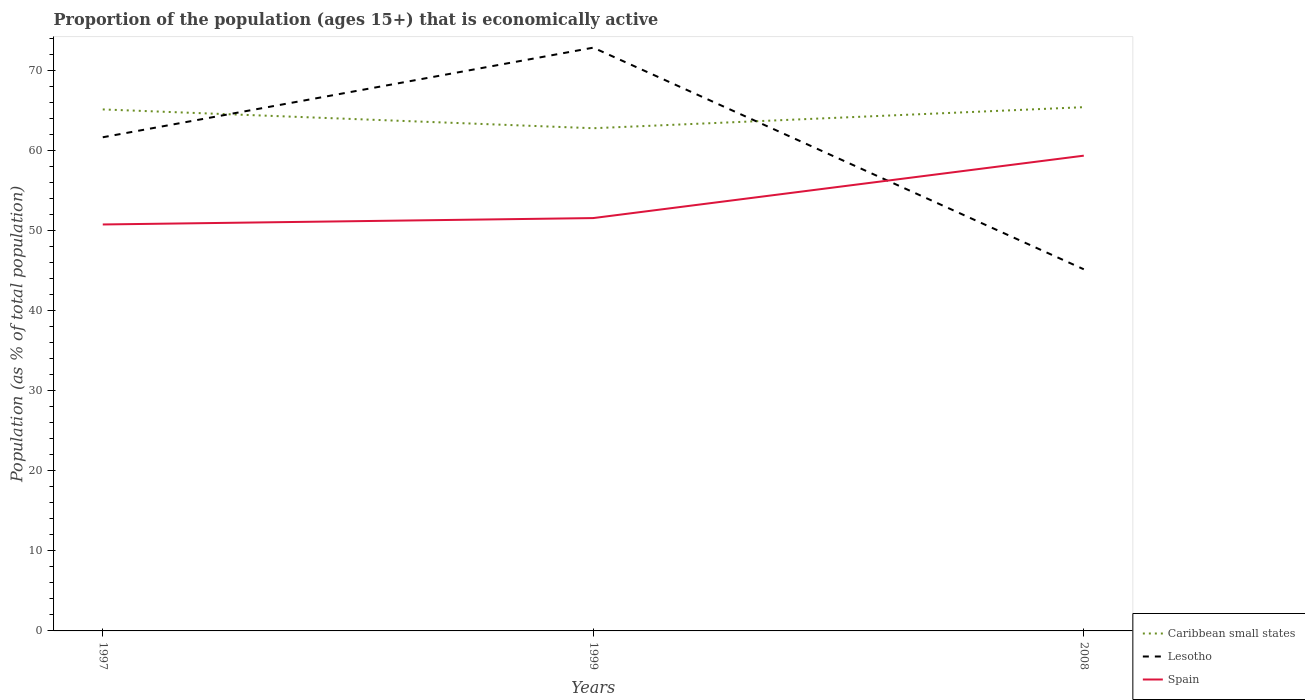Does the line corresponding to Lesotho intersect with the line corresponding to Spain?
Make the answer very short. Yes. Is the number of lines equal to the number of legend labels?
Provide a succinct answer. Yes. Across all years, what is the maximum proportion of the population that is economically active in Lesotho?
Give a very brief answer. 45.2. What is the total proportion of the population that is economically active in Spain in the graph?
Your response must be concise. -7.8. What is the difference between the highest and the second highest proportion of the population that is economically active in Spain?
Give a very brief answer. 8.6. Is the proportion of the population that is economically active in Lesotho strictly greater than the proportion of the population that is economically active in Caribbean small states over the years?
Offer a very short reply. No. How many lines are there?
Your response must be concise. 3. How many years are there in the graph?
Your answer should be very brief. 3. Does the graph contain any zero values?
Give a very brief answer. No. Does the graph contain grids?
Give a very brief answer. No. Where does the legend appear in the graph?
Make the answer very short. Bottom right. How are the legend labels stacked?
Your response must be concise. Vertical. What is the title of the graph?
Your answer should be compact. Proportion of the population (ages 15+) that is economically active. What is the label or title of the Y-axis?
Provide a short and direct response. Population (as % of total population). What is the Population (as % of total population) in Caribbean small states in 1997?
Provide a short and direct response. 65.18. What is the Population (as % of total population) of Lesotho in 1997?
Make the answer very short. 61.7. What is the Population (as % of total population) in Spain in 1997?
Ensure brevity in your answer.  50.8. What is the Population (as % of total population) in Caribbean small states in 1999?
Ensure brevity in your answer.  62.83. What is the Population (as % of total population) in Lesotho in 1999?
Keep it short and to the point. 72.9. What is the Population (as % of total population) of Spain in 1999?
Make the answer very short. 51.6. What is the Population (as % of total population) of Caribbean small states in 2008?
Provide a short and direct response. 65.46. What is the Population (as % of total population) in Lesotho in 2008?
Keep it short and to the point. 45.2. What is the Population (as % of total population) in Spain in 2008?
Provide a short and direct response. 59.4. Across all years, what is the maximum Population (as % of total population) in Caribbean small states?
Provide a succinct answer. 65.46. Across all years, what is the maximum Population (as % of total population) of Lesotho?
Your answer should be compact. 72.9. Across all years, what is the maximum Population (as % of total population) of Spain?
Make the answer very short. 59.4. Across all years, what is the minimum Population (as % of total population) in Caribbean small states?
Provide a succinct answer. 62.83. Across all years, what is the minimum Population (as % of total population) of Lesotho?
Offer a terse response. 45.2. Across all years, what is the minimum Population (as % of total population) of Spain?
Your response must be concise. 50.8. What is the total Population (as % of total population) in Caribbean small states in the graph?
Give a very brief answer. 193.47. What is the total Population (as % of total population) in Lesotho in the graph?
Provide a short and direct response. 179.8. What is the total Population (as % of total population) in Spain in the graph?
Your answer should be very brief. 161.8. What is the difference between the Population (as % of total population) in Caribbean small states in 1997 and that in 1999?
Offer a very short reply. 2.35. What is the difference between the Population (as % of total population) of Lesotho in 1997 and that in 1999?
Offer a very short reply. -11.2. What is the difference between the Population (as % of total population) of Spain in 1997 and that in 1999?
Your answer should be very brief. -0.8. What is the difference between the Population (as % of total population) of Caribbean small states in 1997 and that in 2008?
Offer a very short reply. -0.28. What is the difference between the Population (as % of total population) in Lesotho in 1997 and that in 2008?
Give a very brief answer. 16.5. What is the difference between the Population (as % of total population) of Spain in 1997 and that in 2008?
Your answer should be very brief. -8.6. What is the difference between the Population (as % of total population) of Caribbean small states in 1999 and that in 2008?
Your answer should be very brief. -2.63. What is the difference between the Population (as % of total population) in Lesotho in 1999 and that in 2008?
Give a very brief answer. 27.7. What is the difference between the Population (as % of total population) in Caribbean small states in 1997 and the Population (as % of total population) in Lesotho in 1999?
Ensure brevity in your answer.  -7.72. What is the difference between the Population (as % of total population) of Caribbean small states in 1997 and the Population (as % of total population) of Spain in 1999?
Give a very brief answer. 13.58. What is the difference between the Population (as % of total population) of Caribbean small states in 1997 and the Population (as % of total population) of Lesotho in 2008?
Keep it short and to the point. 19.98. What is the difference between the Population (as % of total population) in Caribbean small states in 1997 and the Population (as % of total population) in Spain in 2008?
Offer a very short reply. 5.78. What is the difference between the Population (as % of total population) of Lesotho in 1997 and the Population (as % of total population) of Spain in 2008?
Give a very brief answer. 2.3. What is the difference between the Population (as % of total population) of Caribbean small states in 1999 and the Population (as % of total population) of Lesotho in 2008?
Keep it short and to the point. 17.63. What is the difference between the Population (as % of total population) of Caribbean small states in 1999 and the Population (as % of total population) of Spain in 2008?
Offer a very short reply. 3.43. What is the average Population (as % of total population) in Caribbean small states per year?
Your answer should be very brief. 64.49. What is the average Population (as % of total population) in Lesotho per year?
Keep it short and to the point. 59.93. What is the average Population (as % of total population) in Spain per year?
Offer a very short reply. 53.93. In the year 1997, what is the difference between the Population (as % of total population) in Caribbean small states and Population (as % of total population) in Lesotho?
Your answer should be very brief. 3.48. In the year 1997, what is the difference between the Population (as % of total population) of Caribbean small states and Population (as % of total population) of Spain?
Give a very brief answer. 14.38. In the year 1997, what is the difference between the Population (as % of total population) in Lesotho and Population (as % of total population) in Spain?
Keep it short and to the point. 10.9. In the year 1999, what is the difference between the Population (as % of total population) in Caribbean small states and Population (as % of total population) in Lesotho?
Provide a short and direct response. -10.07. In the year 1999, what is the difference between the Population (as % of total population) of Caribbean small states and Population (as % of total population) of Spain?
Keep it short and to the point. 11.23. In the year 1999, what is the difference between the Population (as % of total population) of Lesotho and Population (as % of total population) of Spain?
Your response must be concise. 21.3. In the year 2008, what is the difference between the Population (as % of total population) in Caribbean small states and Population (as % of total population) in Lesotho?
Make the answer very short. 20.26. In the year 2008, what is the difference between the Population (as % of total population) in Caribbean small states and Population (as % of total population) in Spain?
Your answer should be compact. 6.06. In the year 2008, what is the difference between the Population (as % of total population) of Lesotho and Population (as % of total population) of Spain?
Provide a short and direct response. -14.2. What is the ratio of the Population (as % of total population) of Caribbean small states in 1997 to that in 1999?
Your response must be concise. 1.04. What is the ratio of the Population (as % of total population) in Lesotho in 1997 to that in 1999?
Give a very brief answer. 0.85. What is the ratio of the Population (as % of total population) in Spain in 1997 to that in 1999?
Make the answer very short. 0.98. What is the ratio of the Population (as % of total population) in Lesotho in 1997 to that in 2008?
Your answer should be compact. 1.36. What is the ratio of the Population (as % of total population) in Spain in 1997 to that in 2008?
Keep it short and to the point. 0.86. What is the ratio of the Population (as % of total population) of Caribbean small states in 1999 to that in 2008?
Give a very brief answer. 0.96. What is the ratio of the Population (as % of total population) in Lesotho in 1999 to that in 2008?
Offer a very short reply. 1.61. What is the ratio of the Population (as % of total population) in Spain in 1999 to that in 2008?
Offer a very short reply. 0.87. What is the difference between the highest and the second highest Population (as % of total population) of Caribbean small states?
Make the answer very short. 0.28. What is the difference between the highest and the second highest Population (as % of total population) of Spain?
Provide a succinct answer. 7.8. What is the difference between the highest and the lowest Population (as % of total population) in Caribbean small states?
Make the answer very short. 2.63. What is the difference between the highest and the lowest Population (as % of total population) in Lesotho?
Make the answer very short. 27.7. 